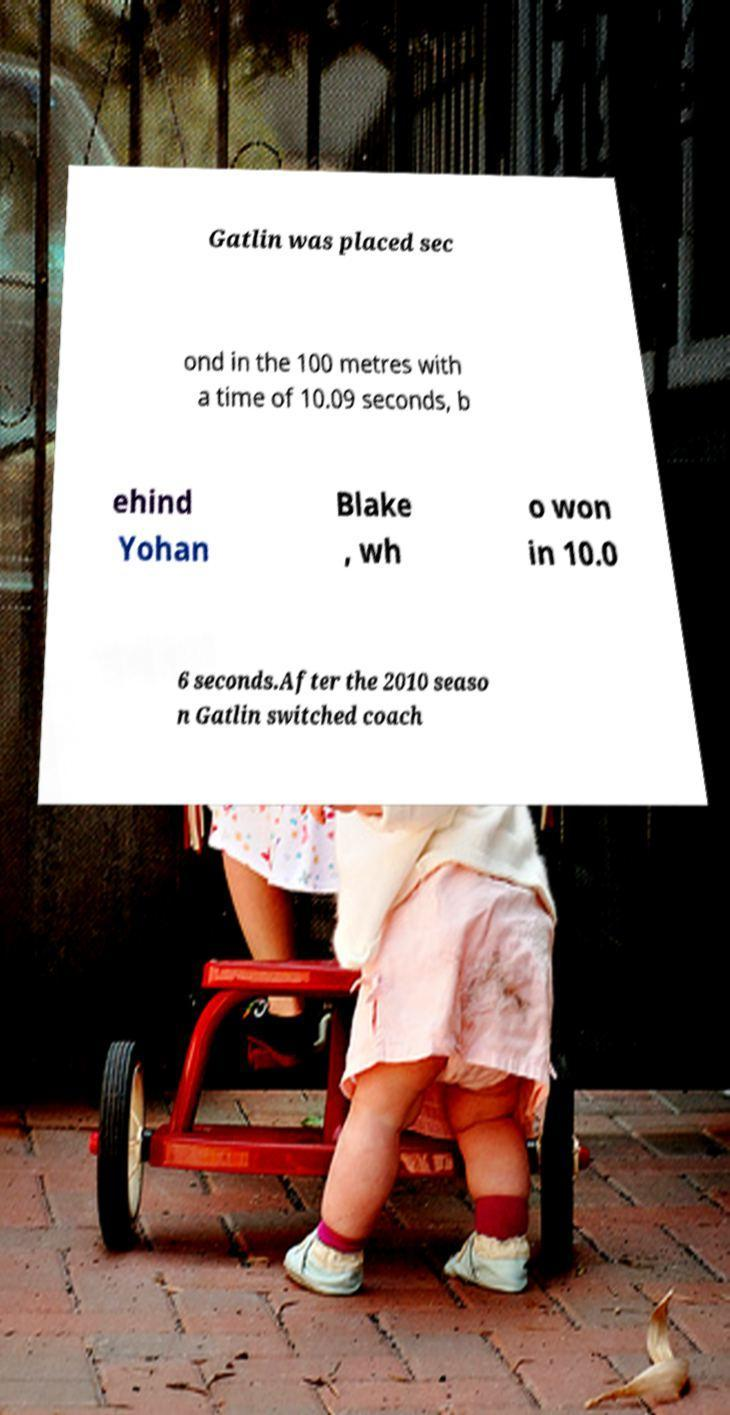For documentation purposes, I need the text within this image transcribed. Could you provide that? Gatlin was placed sec ond in the 100 metres with a time of 10.09 seconds, b ehind Yohan Blake , wh o won in 10.0 6 seconds.After the 2010 seaso n Gatlin switched coach 